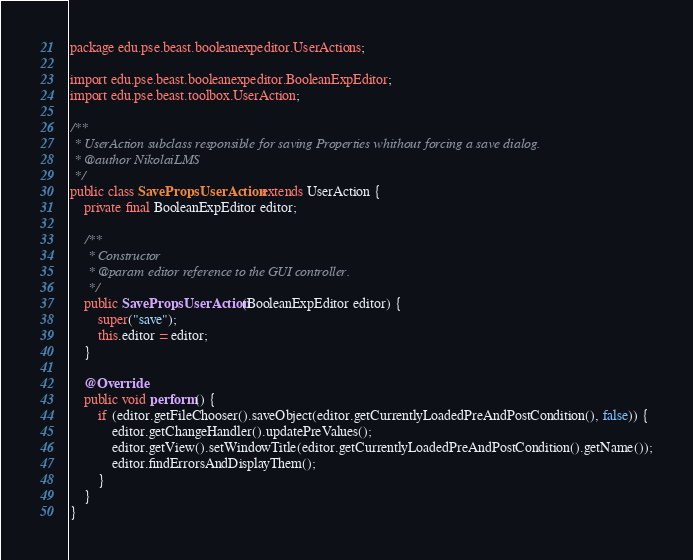<code> <loc_0><loc_0><loc_500><loc_500><_Java_>package edu.pse.beast.booleanexpeditor.UserActions;

import edu.pse.beast.booleanexpeditor.BooleanExpEditor;
import edu.pse.beast.toolbox.UserAction;

/**
 * UserAction subclass responsible for saving Properties whithout forcing a save dialog.
 * @author NikolaiLMS
 */
public class SavePropsUserAction extends UserAction {
    private final BooleanExpEditor editor;

    /**
     * Constructor
     * @param editor reference to the GUI controller.
     */
    public SavePropsUserAction(BooleanExpEditor editor) {
        super("save");
        this.editor = editor;
    }

    @Override
    public void perform() {
        if (editor.getFileChooser().saveObject(editor.getCurrentlyLoadedPreAndPostCondition(), false)) {
            editor.getChangeHandler().updatePreValues();
            editor.getView().setWindowTitle(editor.getCurrentlyLoadedPreAndPostCondition().getName());
            editor.findErrorsAndDisplayThem();
        }
    }
}
</code> 